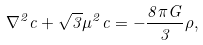<formula> <loc_0><loc_0><loc_500><loc_500>\nabla ^ { 2 } c + \sqrt { 3 } \mu ^ { 2 } c = - \frac { 8 \pi G } { 3 } \rho ,</formula> 